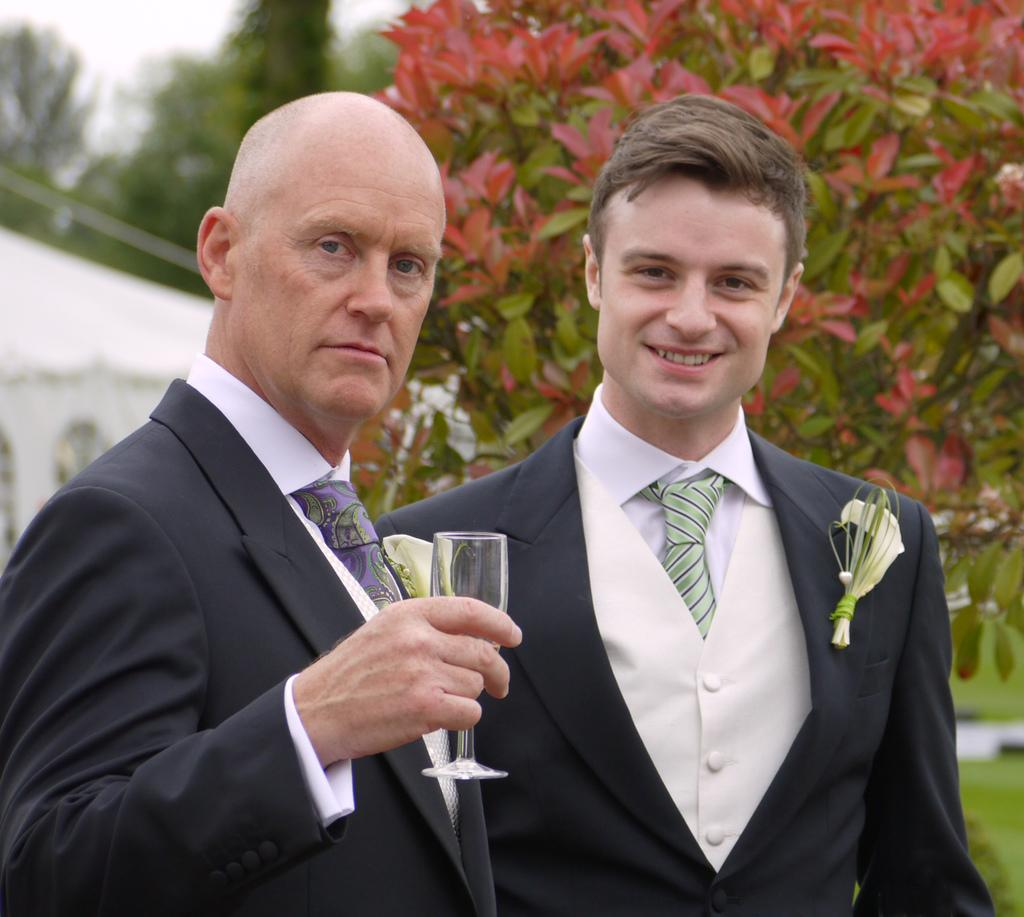How many people are in the image? There are two men standing in the image. What is one of the men holding in his hand? One of the men is holding a glass in his hand. What type of vegetation can be seen in the image? There are leaves visible in the image. Can you describe the background of the image? The background of the image is blurred. What type of ticket is the man holding in the image? There is no ticket present in the image; one of the men is holding a glass. What is the opinion of the man standing on the left side of the image? There is no indication of the man's opinion in the image. 